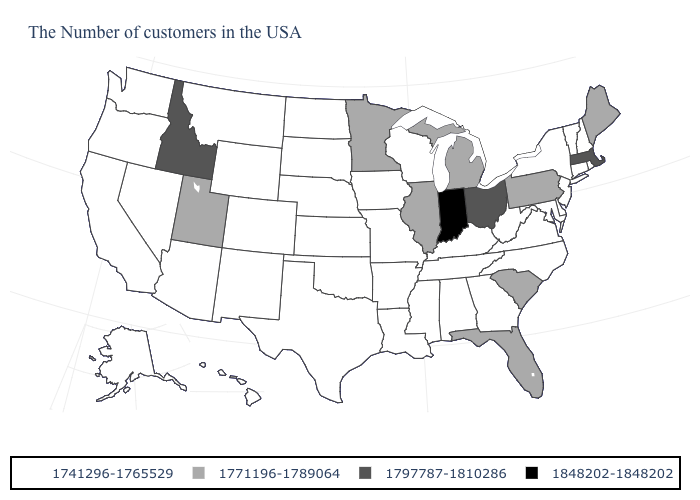What is the value of New Hampshire?
Be succinct. 1741296-1765529. What is the value of Kentucky?
Write a very short answer. 1741296-1765529. Which states hav the highest value in the West?
Be succinct. Idaho. Does Idaho have a higher value than Massachusetts?
Answer briefly. No. Among the states that border Georgia , which have the highest value?
Concise answer only. South Carolina, Florida. Among the states that border Missouri , which have the lowest value?
Concise answer only. Kentucky, Tennessee, Arkansas, Iowa, Kansas, Nebraska, Oklahoma. Does the map have missing data?
Short answer required. No. What is the value of Kentucky?
Answer briefly. 1741296-1765529. Name the states that have a value in the range 1771196-1789064?
Quick response, please. Maine, Pennsylvania, South Carolina, Florida, Michigan, Illinois, Minnesota, Utah. What is the value of West Virginia?
Give a very brief answer. 1741296-1765529. Is the legend a continuous bar?
Short answer required. No. Name the states that have a value in the range 1741296-1765529?
Give a very brief answer. Rhode Island, New Hampshire, Vermont, Connecticut, New York, New Jersey, Delaware, Maryland, Virginia, North Carolina, West Virginia, Georgia, Kentucky, Alabama, Tennessee, Wisconsin, Mississippi, Louisiana, Missouri, Arkansas, Iowa, Kansas, Nebraska, Oklahoma, Texas, South Dakota, North Dakota, Wyoming, Colorado, New Mexico, Montana, Arizona, Nevada, California, Washington, Oregon, Alaska, Hawaii. Which states have the highest value in the USA?
Give a very brief answer. Indiana. Among the states that border Montana , which have the lowest value?
Write a very short answer. South Dakota, North Dakota, Wyoming. Name the states that have a value in the range 1848202-1848202?
Keep it brief. Indiana. 